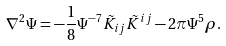Convert formula to latex. <formula><loc_0><loc_0><loc_500><loc_500>\nabla ^ { 2 } \Psi = - \frac { 1 } { 8 } \Psi ^ { - 7 } \tilde { K } _ { i j } \tilde { K } ^ { i j } - 2 \pi \Psi ^ { 5 } \rho .</formula> 